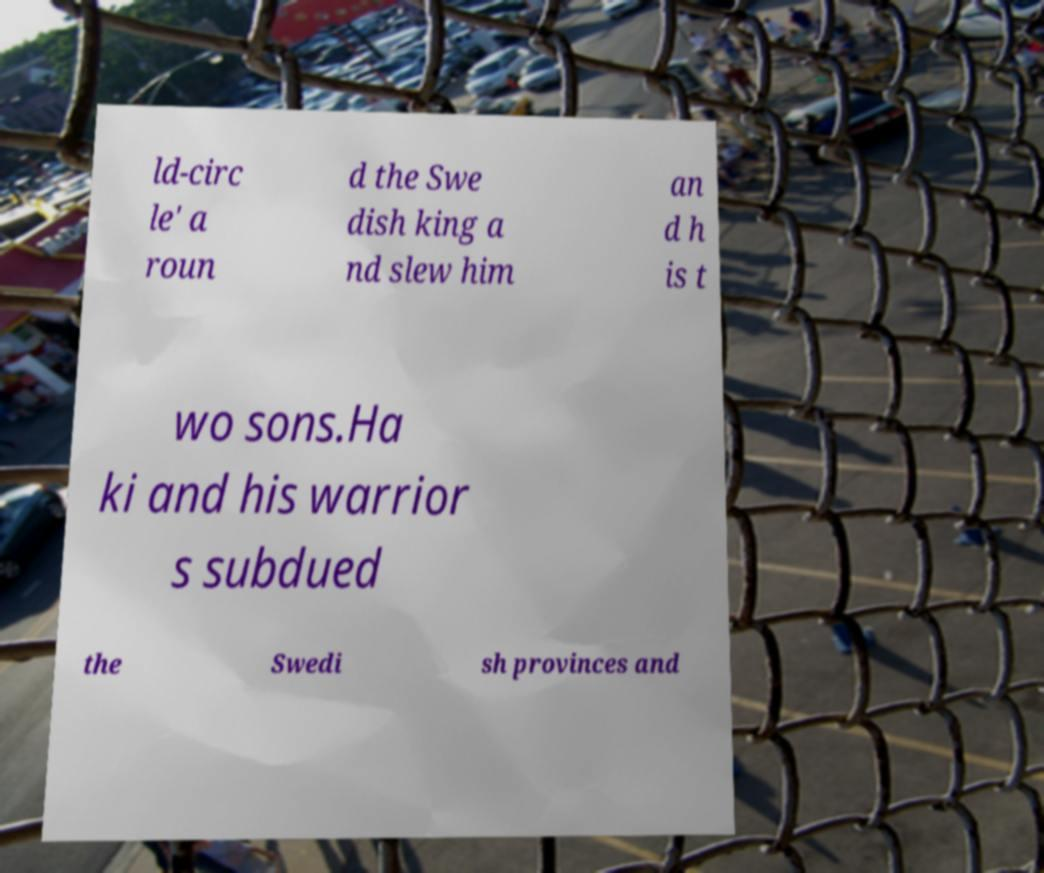Can you read and provide the text displayed in the image?This photo seems to have some interesting text. Can you extract and type it out for me? ld-circ le' a roun d the Swe dish king a nd slew him an d h is t wo sons.Ha ki and his warrior s subdued the Swedi sh provinces and 